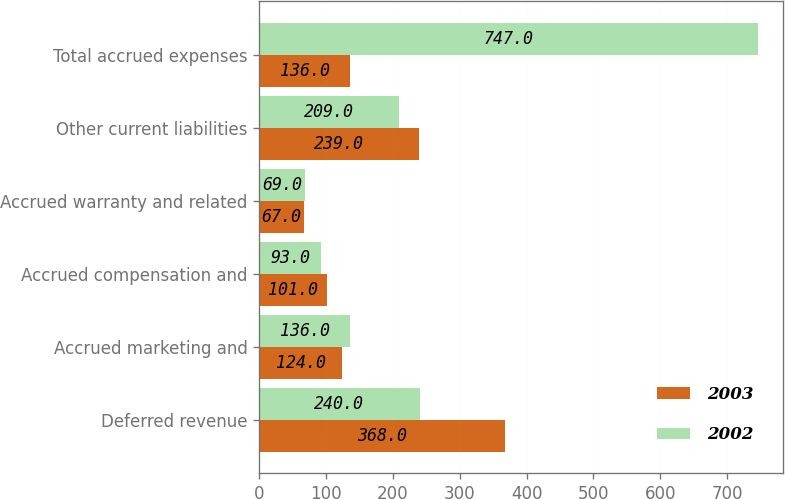<chart> <loc_0><loc_0><loc_500><loc_500><stacked_bar_chart><ecel><fcel>Deferred revenue<fcel>Accrued marketing and<fcel>Accrued compensation and<fcel>Accrued warranty and related<fcel>Other current liabilities<fcel>Total accrued expenses<nl><fcel>2003<fcel>368<fcel>124<fcel>101<fcel>67<fcel>239<fcel>136<nl><fcel>2002<fcel>240<fcel>136<fcel>93<fcel>69<fcel>209<fcel>747<nl></chart> 